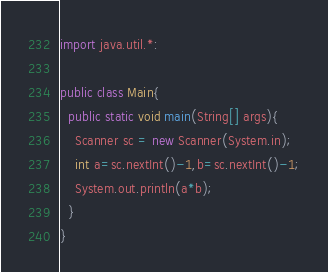Convert code to text. <code><loc_0><loc_0><loc_500><loc_500><_Java_>import java.util.*:

public class Main{
  public static void main(String[] args){
    Scanner sc = new Scanner(System.in);
    int a=sc.nextInt()-1,b=sc.nextInt()-1;
    System.out.println(a*b);
  }
}</code> 